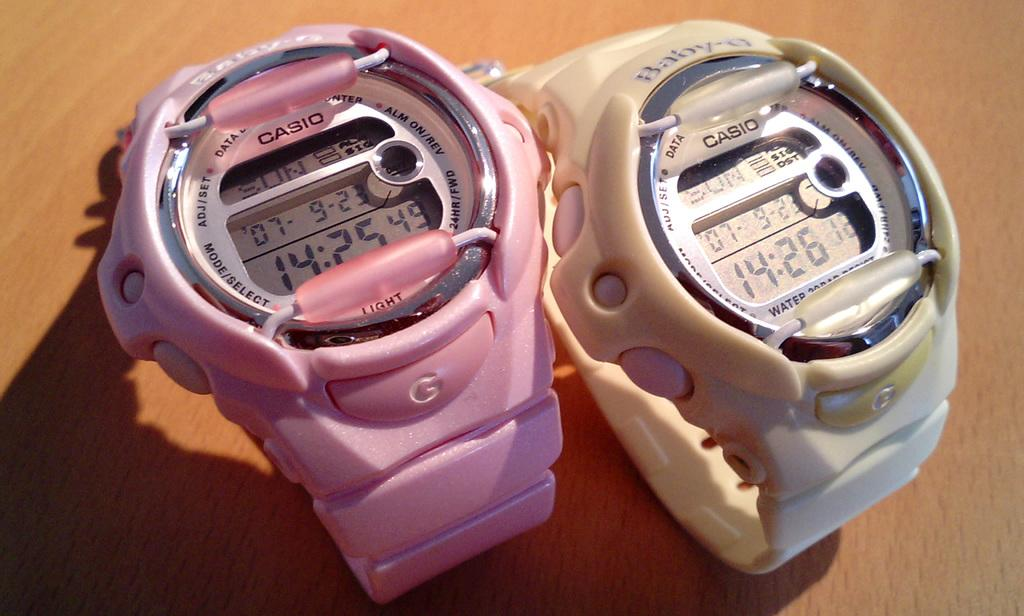What is the color of the surface in the image? The surface in the image is brown in color. What objects can be seen on the surface? There are two wrist watches on the surface. What colors are the wrist watches? One wrist watch is cream in color, and the other is pink in color. What type of bait is used to catch fish in the image? There is no bait or fishing activity present in the image. Can you tell me the size of the ring on the pink wrist watch? There is no ring present on the pink wrist watch in the image. 